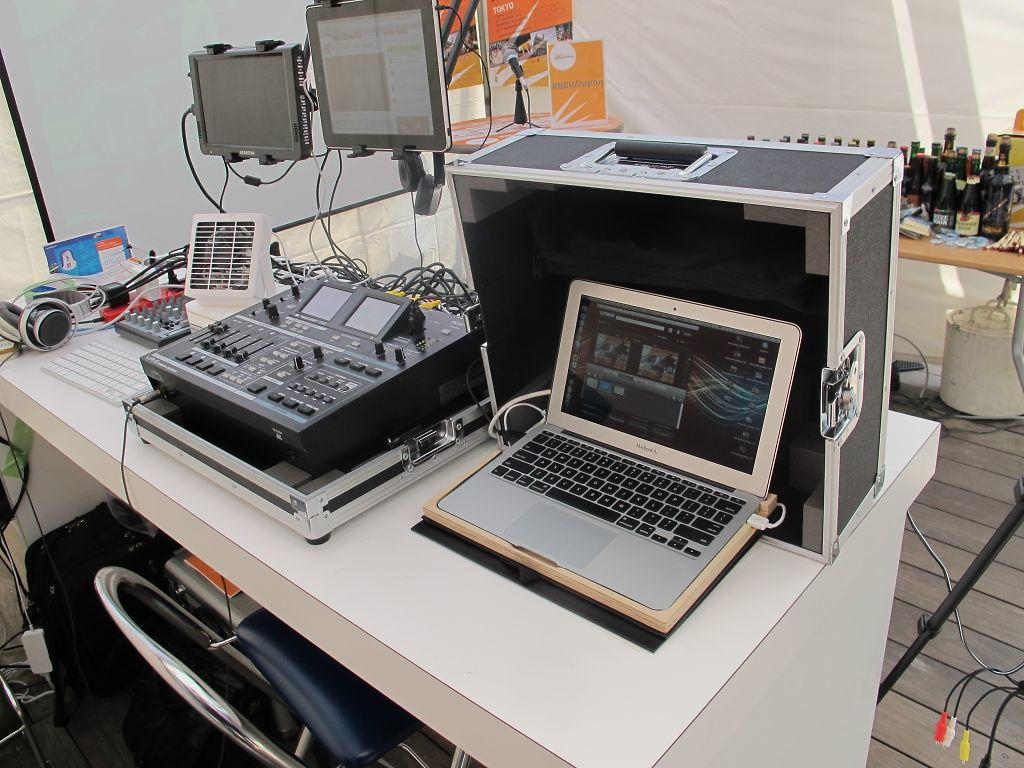What is the main object in the middle of the image? There is a table in the middle of the image. What electronic device is on the table? A laptop is present on the table. What is another object related to the laptop on the table? A keyboard is on the table. What type of items are also on the table? There are instruments on the table. Can you describe the background of the image? In the background, there is a microphone, another table, bottles, a whiteboard, and a tent. How many men are engaged in a battle in the image? There are no men or battle present in the image. What type of car can be seen in the background of the image? There is no car present in the image. 